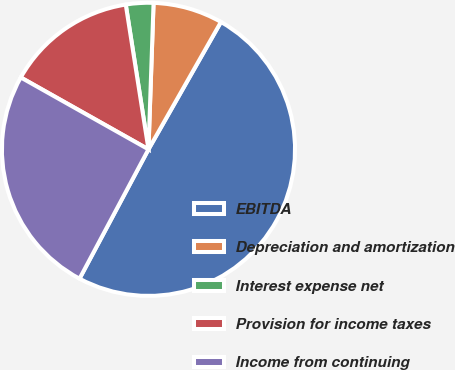Convert chart. <chart><loc_0><loc_0><loc_500><loc_500><pie_chart><fcel>EBITDA<fcel>Depreciation and amortization<fcel>Interest expense net<fcel>Provision for income taxes<fcel>Income from continuing<nl><fcel>49.56%<fcel>7.68%<fcel>3.03%<fcel>14.36%<fcel>25.36%<nl></chart> 